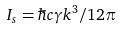Convert formula to latex. <formula><loc_0><loc_0><loc_500><loc_500>I _ { s } = \hbar { c } \gamma k ^ { 3 } / 1 2 \pi</formula> 